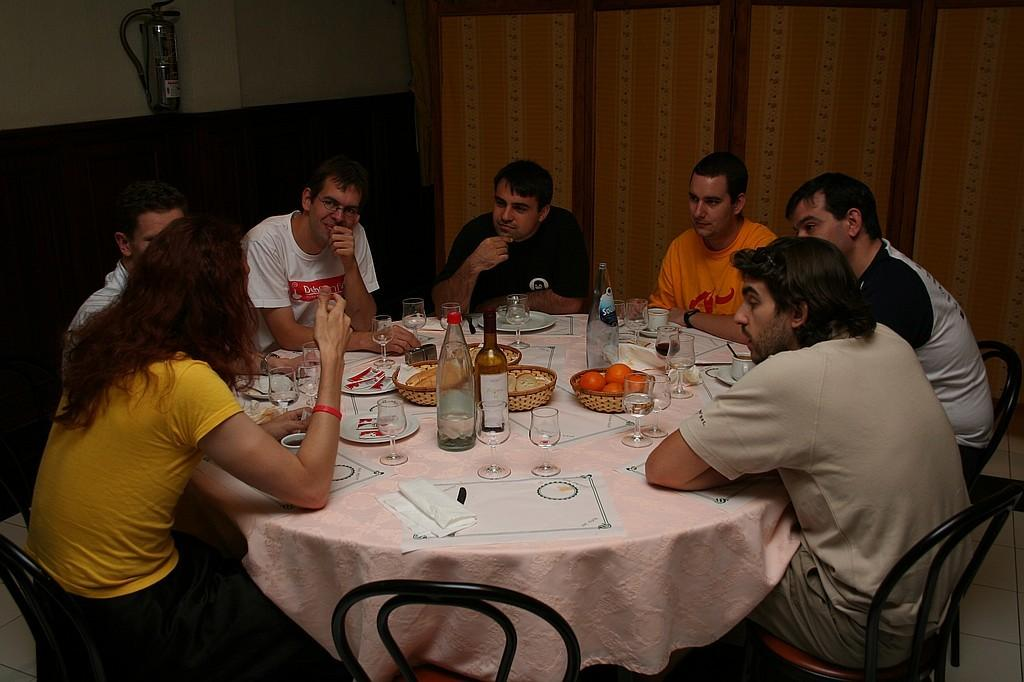How many people are in the image? There are many people in the image. What are the people doing in the image? The people are sitting in chairs. How are the chairs arranged in the image? The chairs are arranged around a table. What items can be seen on the table in the image? There are different items on the table, including glasses, bottles, fruits, knives, and plates. How does the island control the flow of water in the image? There is no island present in the image, and therefore no control over water flow can be observed. 